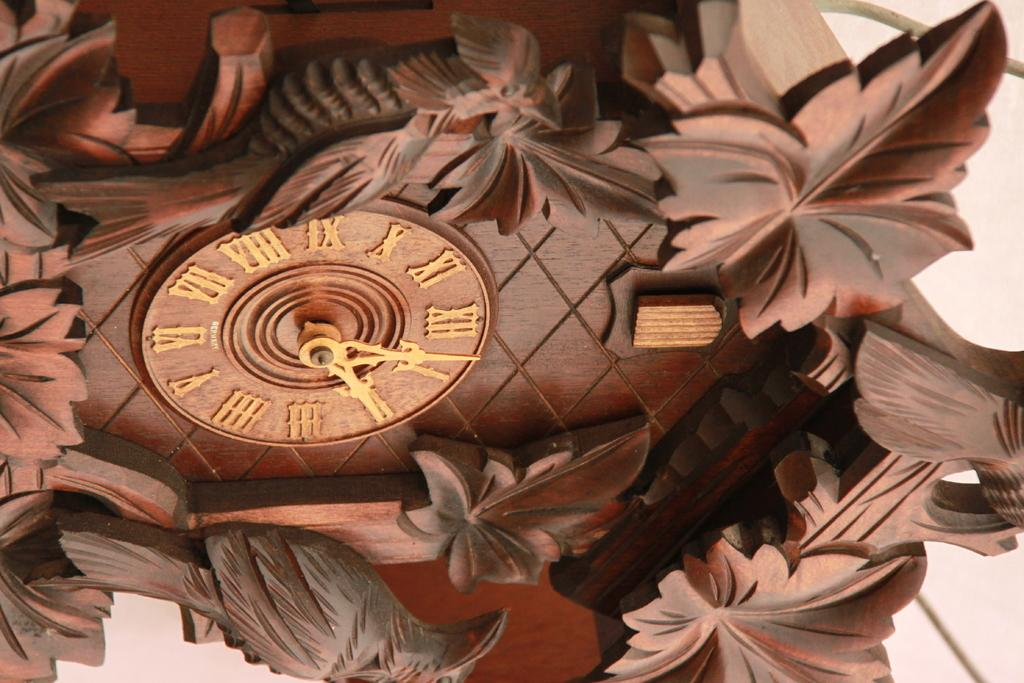<image>
Create a compact narrative representing the image presented. Old clock with carvings of leaves on it and the hands on number 4 and 3. 